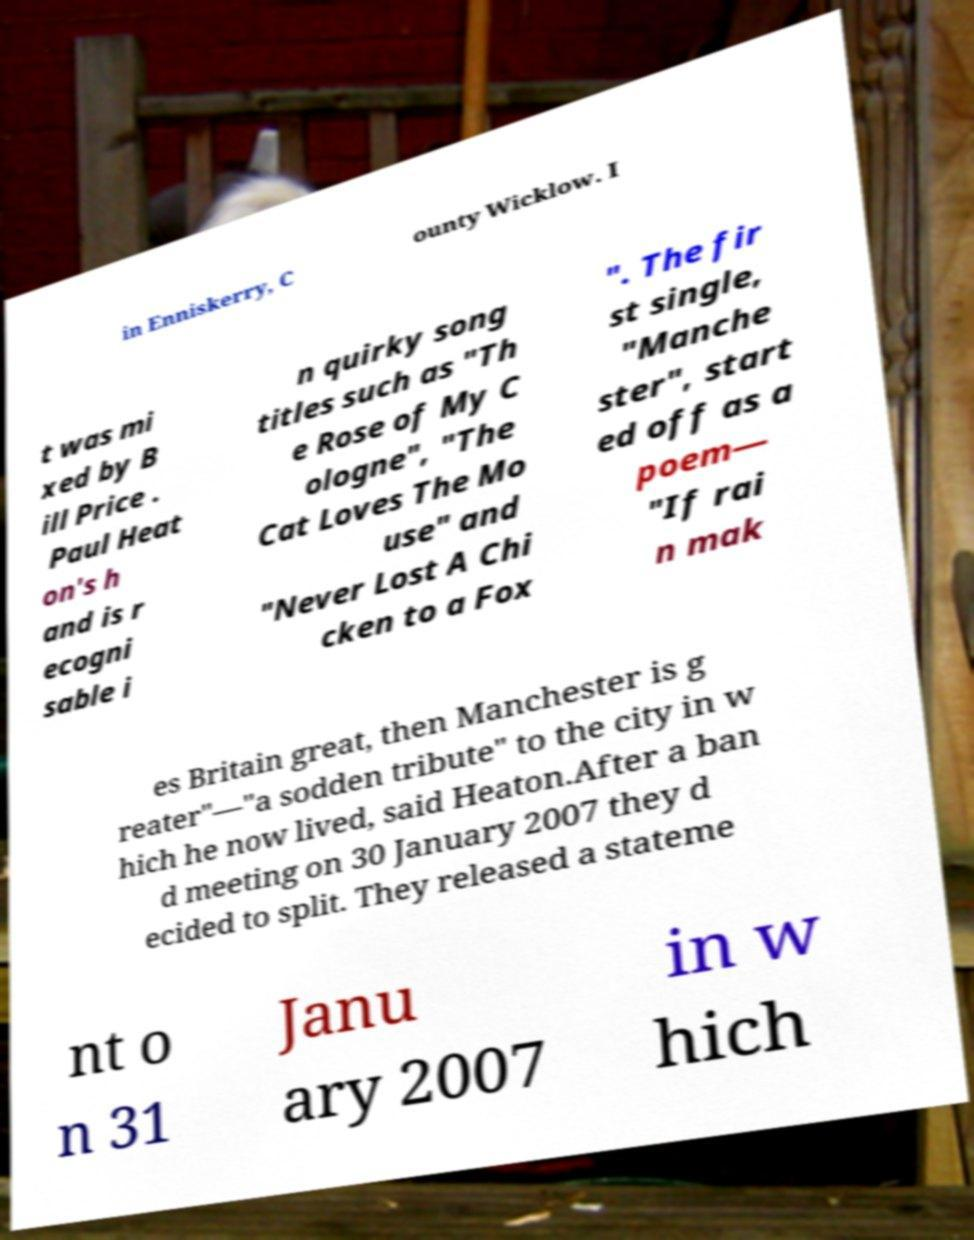What messages or text are displayed in this image? I need them in a readable, typed format. in Enniskerry, C ounty Wicklow. I t was mi xed by B ill Price . Paul Heat on's h and is r ecogni sable i n quirky song titles such as "Th e Rose of My C ologne", "The Cat Loves The Mo use" and "Never Lost A Chi cken to a Fox ". The fir st single, "Manche ster", start ed off as a poem— "If rai n mak es Britain great, then Manchester is g reater"—"a sodden tribute" to the city in w hich he now lived, said Heaton.After a ban d meeting on 30 January 2007 they d ecided to split. They released a stateme nt o n 31 Janu ary 2007 in w hich 